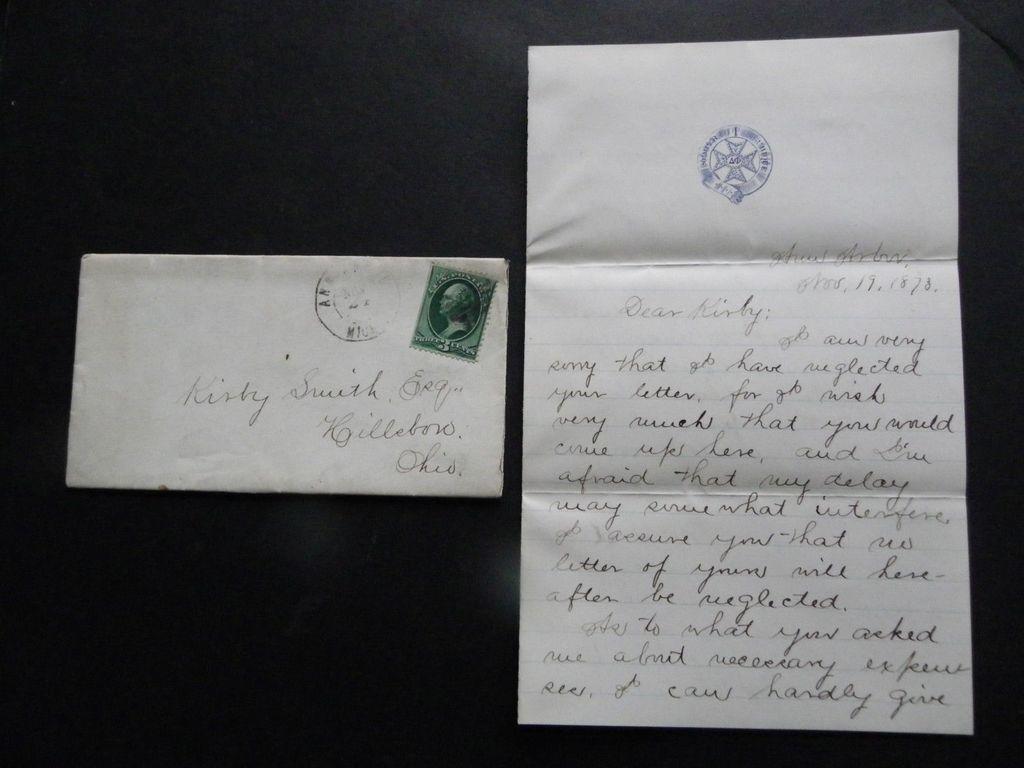Who is this written to?
Provide a succinct answer. Kirby smith. What year was this written?
Provide a succinct answer. 1878. 